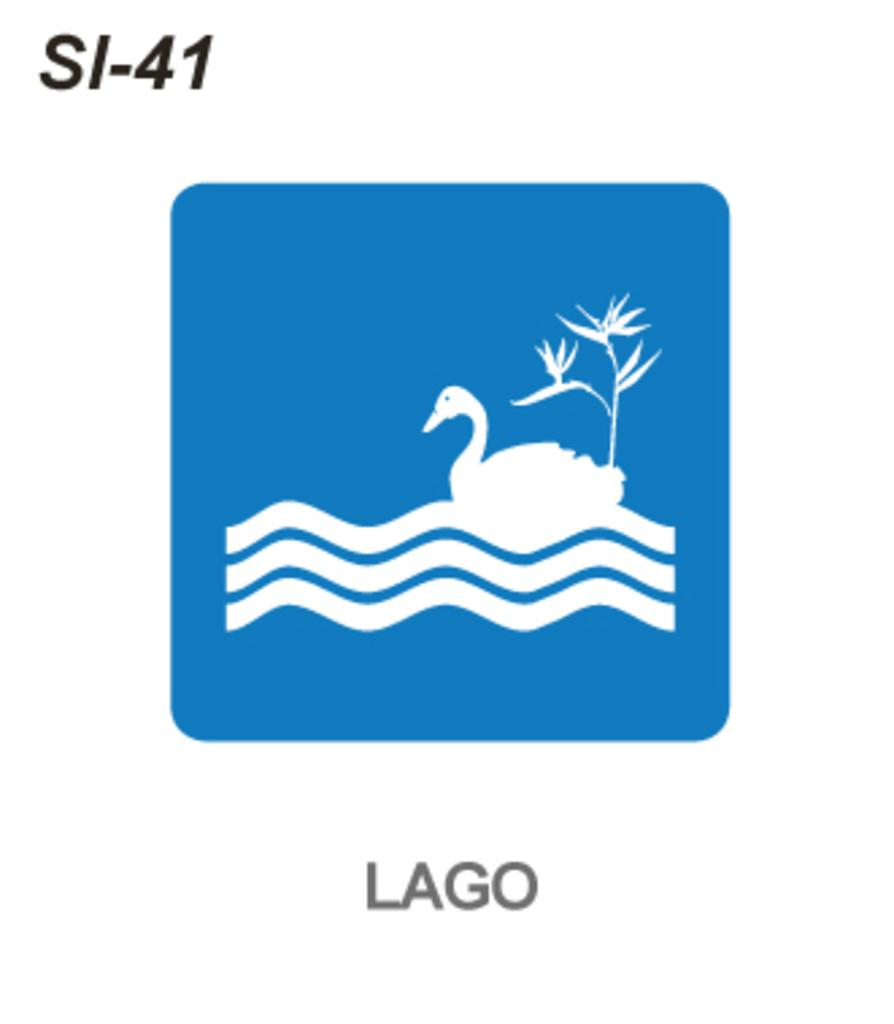What is the main feature of the image? There is a logo in the image. What type of humor is depicted in the logo? There is no humor depicted in the logo, as the image only contains a logo and no other elements. 